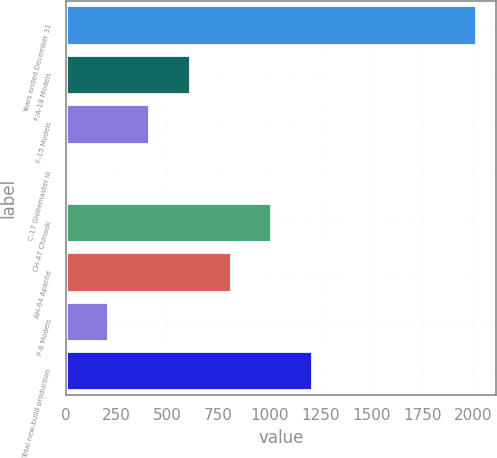Convert chart to OTSL. <chart><loc_0><loc_0><loc_500><loc_500><bar_chart><fcel>Years ended December 31<fcel>F/A-18 Models<fcel>F-15 Models<fcel>C-17 Globemaster III<fcel>CH-47 Chinook<fcel>AH-64 Apache<fcel>P-8 Models<fcel>Total new-build production<nl><fcel>2014<fcel>609.1<fcel>408.4<fcel>7<fcel>1010.5<fcel>809.8<fcel>207.7<fcel>1211.2<nl></chart> 